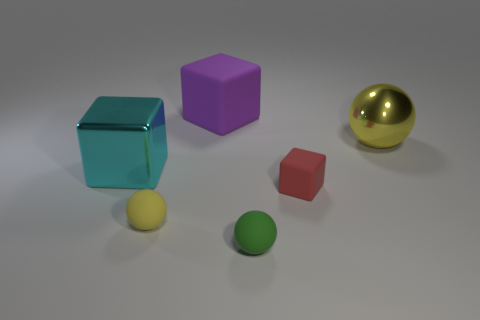How is the lighting affecting the appearance of the objects? The lighting in the image creates subtle shadows and highlights which give depth and dimension to the objects. The reflective surfaces like that of the golden ball and the blue cube are particularly influenced, showing brighter highlights and giving clues about the smoothness of their texture. The matte surface of the purple cube and the other colored shapes scatters light more evenly, softening shadows and reflections. 